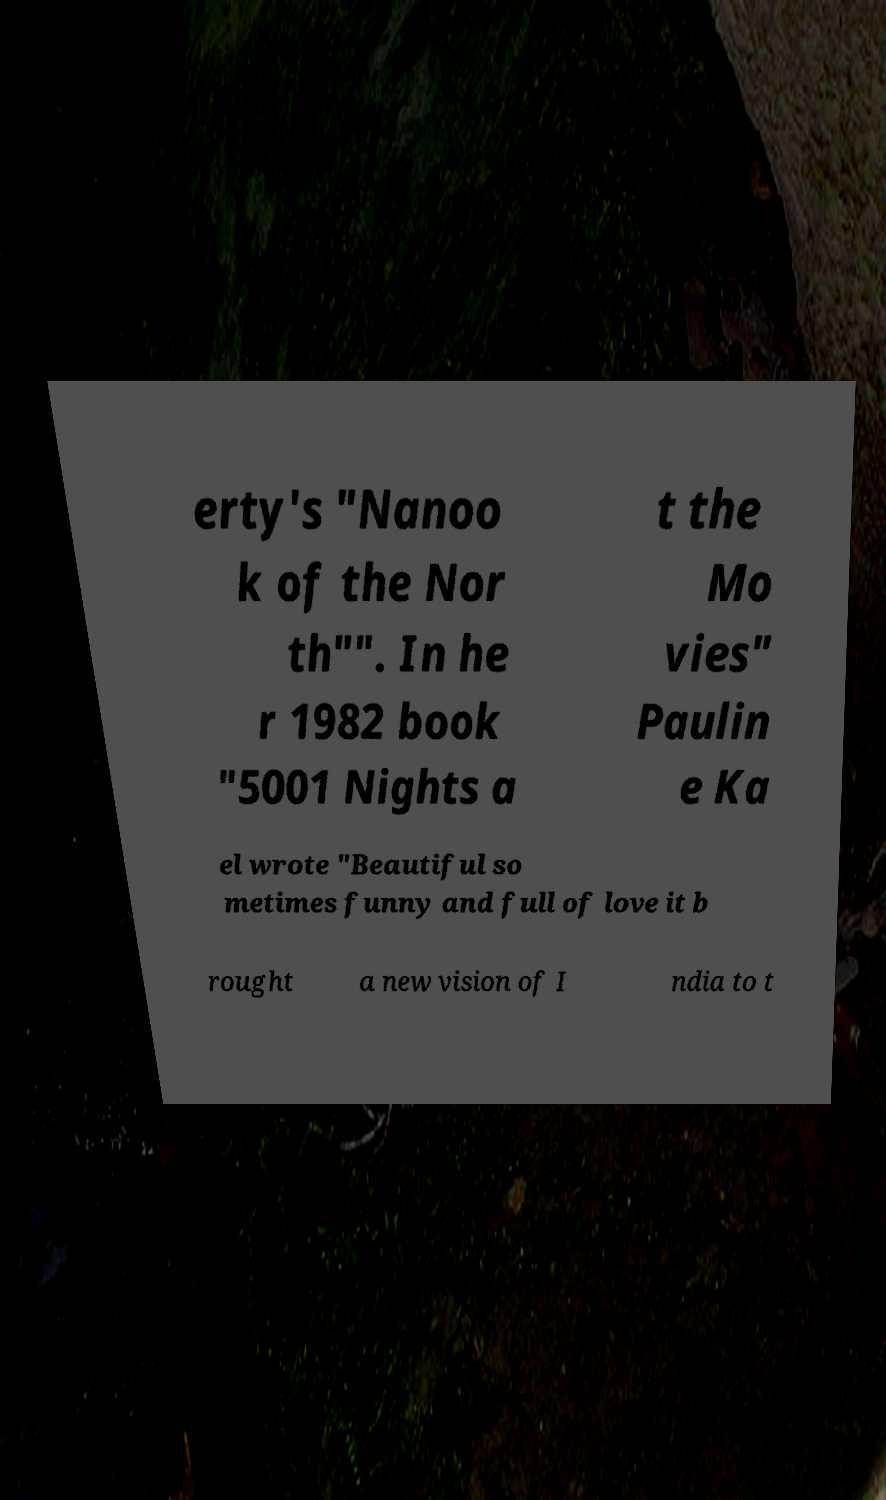Could you extract and type out the text from this image? erty's "Nanoo k of the Nor th"". In he r 1982 book "5001 Nights a t the Mo vies" Paulin e Ka el wrote "Beautiful so metimes funny and full of love it b rought a new vision of I ndia to t 